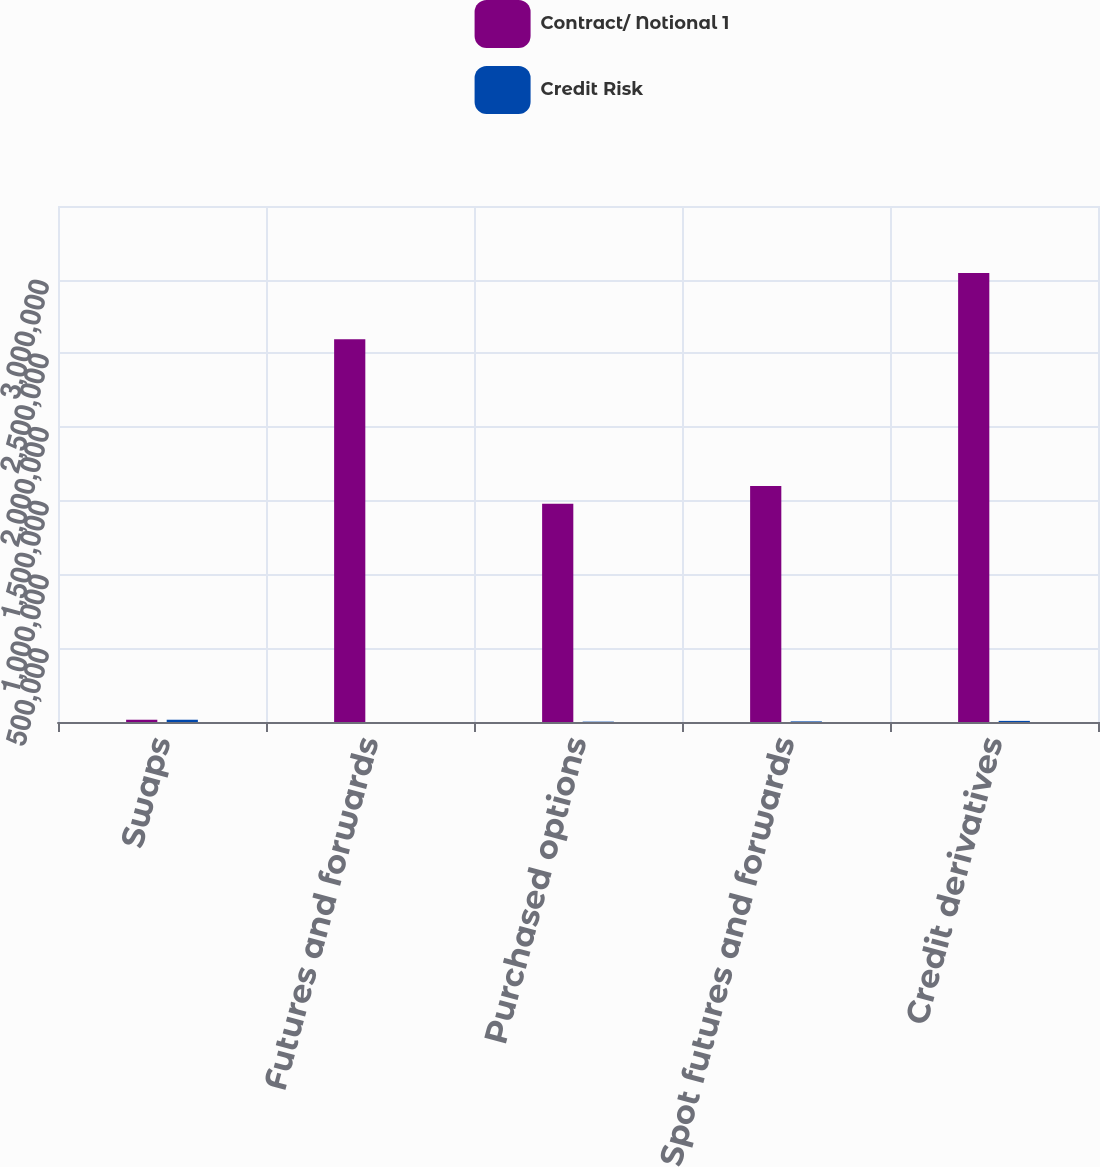Convert chart. <chart><loc_0><loc_0><loc_500><loc_500><stacked_bar_chart><ecel><fcel>Swaps<fcel>Futures and forwards<fcel>Purchased options<fcel>Spot futures and forwards<fcel>Credit derivatives<nl><fcel>Contract/ Notional 1<fcel>15368<fcel>2.59615e+06<fcel>1.47998e+06<fcel>1.60068e+06<fcel>3.04638e+06<nl><fcel>Credit Risk<fcel>15368<fcel>10<fcel>2508<fcel>4124<fcel>7493<nl></chart> 